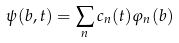<formula> <loc_0><loc_0><loc_500><loc_500>\psi ( b , t ) = \sum _ { n } c _ { n } ( t ) \varphi _ { n } ( b )</formula> 